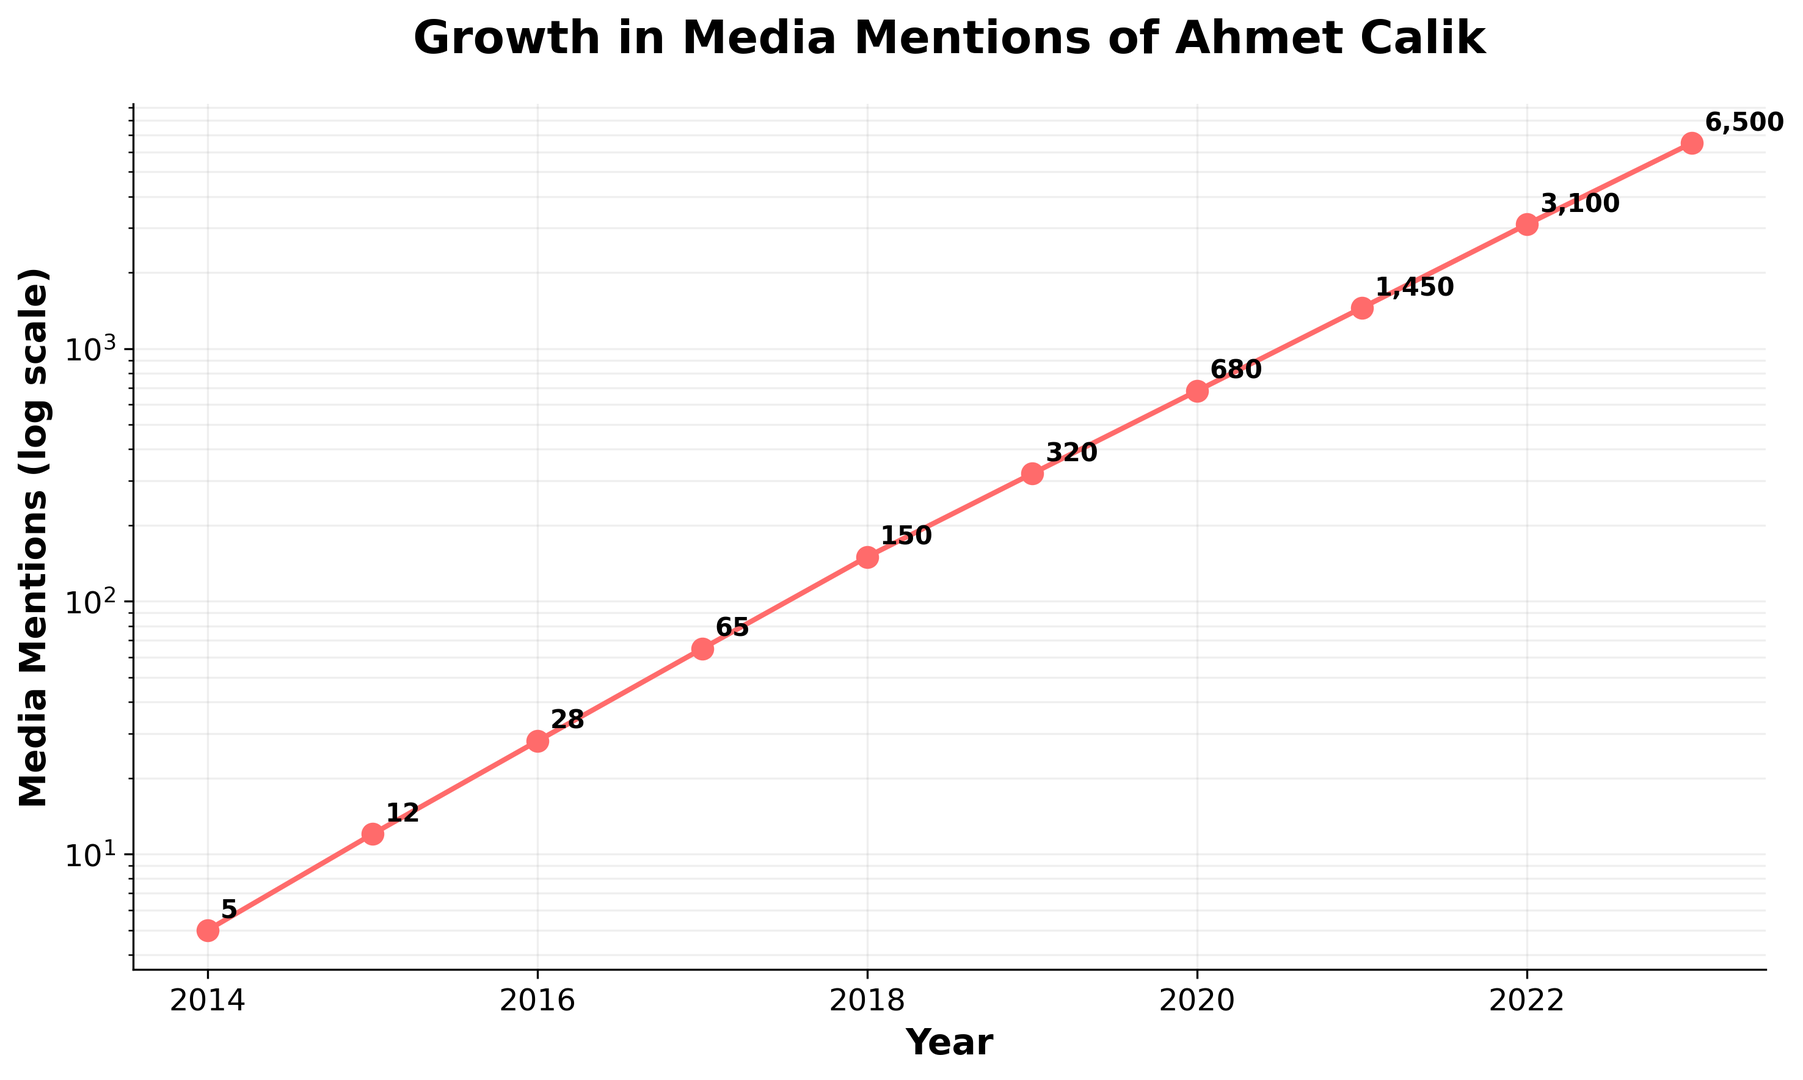What's the overall trend of media mentions for Ahmet Calik between 2014 and 2023? The figure shows a consistent upward trend in media mentions starting from 5 in 2014 to 6500 in 2023. The log scale highlights the exponential growth over these years.
Answer: Upward trend In which year did Ahmet Calik's media mentions first exceed 1000? Looking at the data points on the chart, the year 2021 has 1450 media mentions, which is the first instance over 1000.
Answer: 2021 By how much did media mentions increase from 2017 to 2018? In 2017, media mentions were 65. In 2018, they increased to 150. The increase is calculated by subtracting 65 from 150.
Answer: 85 What's the ratio of media mentions in 2023 compared to 2022? The media mentions in 2023 are 6500, and in 2022 they are 3100. The ratio is found by dividing 6500 by 3100.
Answer: Approximately 2.10 How many years did it take for Ahmet Calik's media mentions to grow from 5 to over 1000? Starting from 2014 with 5 mentions, it took until 2021 for mentions to exceed 1000. The time span is calculated from 2014 to 2021.
Answer: 7 years Examine the year with the highest growth rate in media mentions. What is that year and how much did it increase compared to the previous year? Comparing the slope between the data points each year, the steepest increase is from 2021 (1450 mentions) to 2022 (3100 mentions). The increase is calculated by subtracting 1450 from 3100.
Answer: 2022, 1650 Compare the media mentions between 2020 and 2016. How many times greater are the mentions in 2020 compared to 2016? In 2016, media mentions were 28, and in 2020, mentions were 680. The number of times greater is calculated by dividing 680 by 28.
Answer: Approximately 24.29 What is the compound annual growth rate (CAGR) of Ahmet Calik's media mentions from 2014 to 2023? Calculate the CAGR using the formula: \(CAGR = \left(\frac{Ending\:Value}{Beginning\:Value}\right)^{\frac{1}{Number\:of\:Years}} - 1\). Plugging in 6500 (2023) and 5 (2014) over 9 years: \(CAGR = \left(\frac{6500}{5}\right)^{\frac{1}{9}} - 1\).
Answer: Approximately 83.77% During which year did Ahmet Calik experience media mentions that were approximately doubled from the previous year? By observing the chart, in 2018, the media mentions are 150, which is about double the 2017 mentions of 65.
Answer: 2018 Find the average annual increase in media mentions from 2014 to 2023. Calculate the overall increase from 2014 (5) to 2023 (6500) and divide by the number of years. \( \frac{6500-5}{2023-2014} = \frac{6495}{9} \).
Answer: Approximately 722.78 